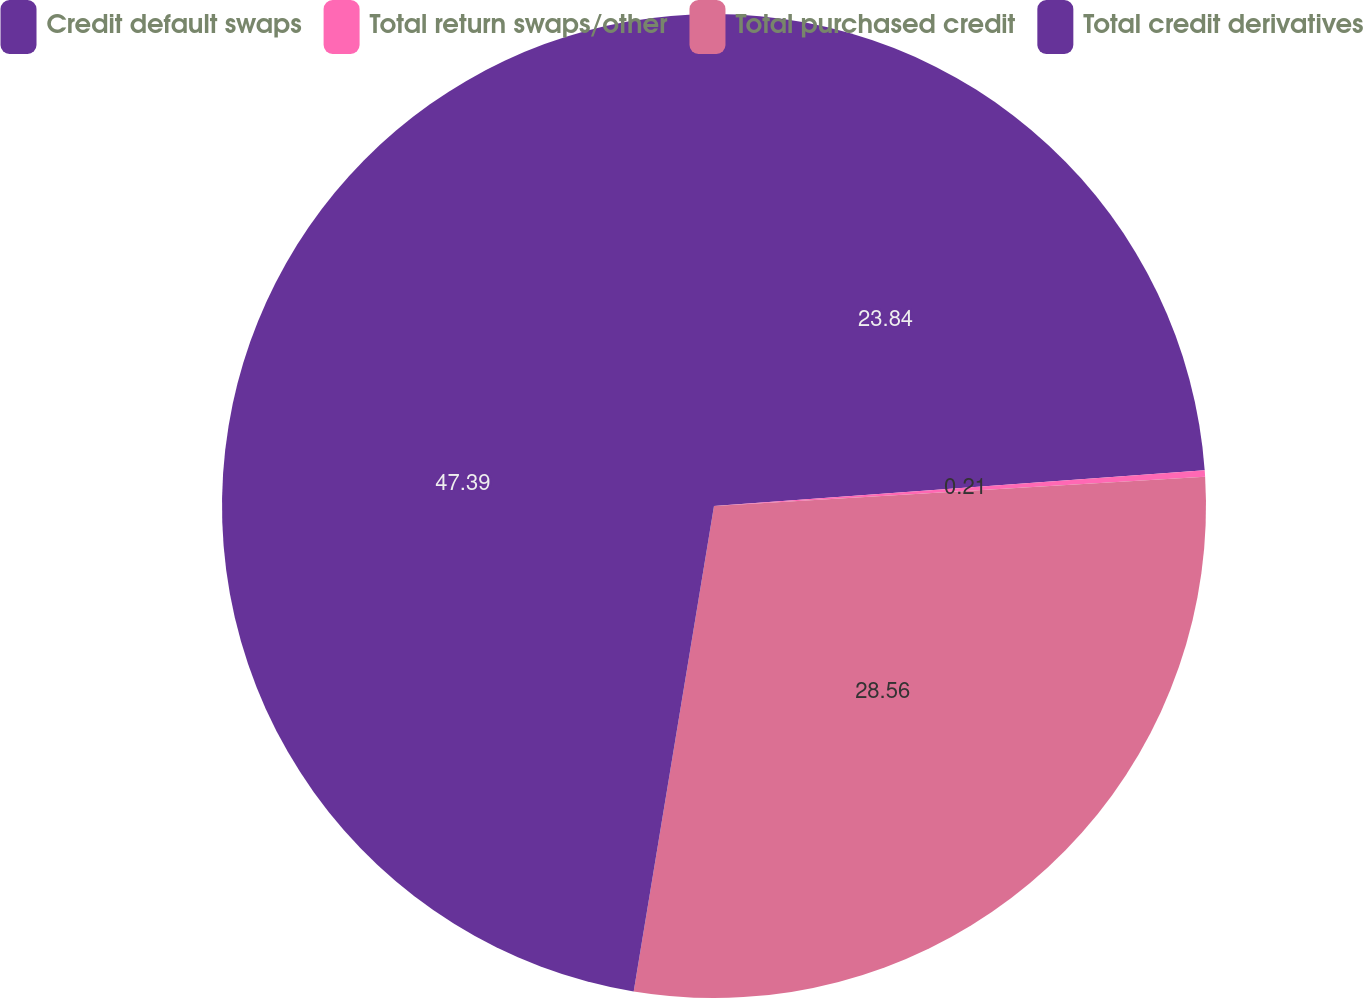Convert chart. <chart><loc_0><loc_0><loc_500><loc_500><pie_chart><fcel>Credit default swaps<fcel>Total return swaps/other<fcel>Total purchased credit<fcel>Total credit derivatives<nl><fcel>23.84%<fcel>0.21%<fcel>28.56%<fcel>47.39%<nl></chart> 